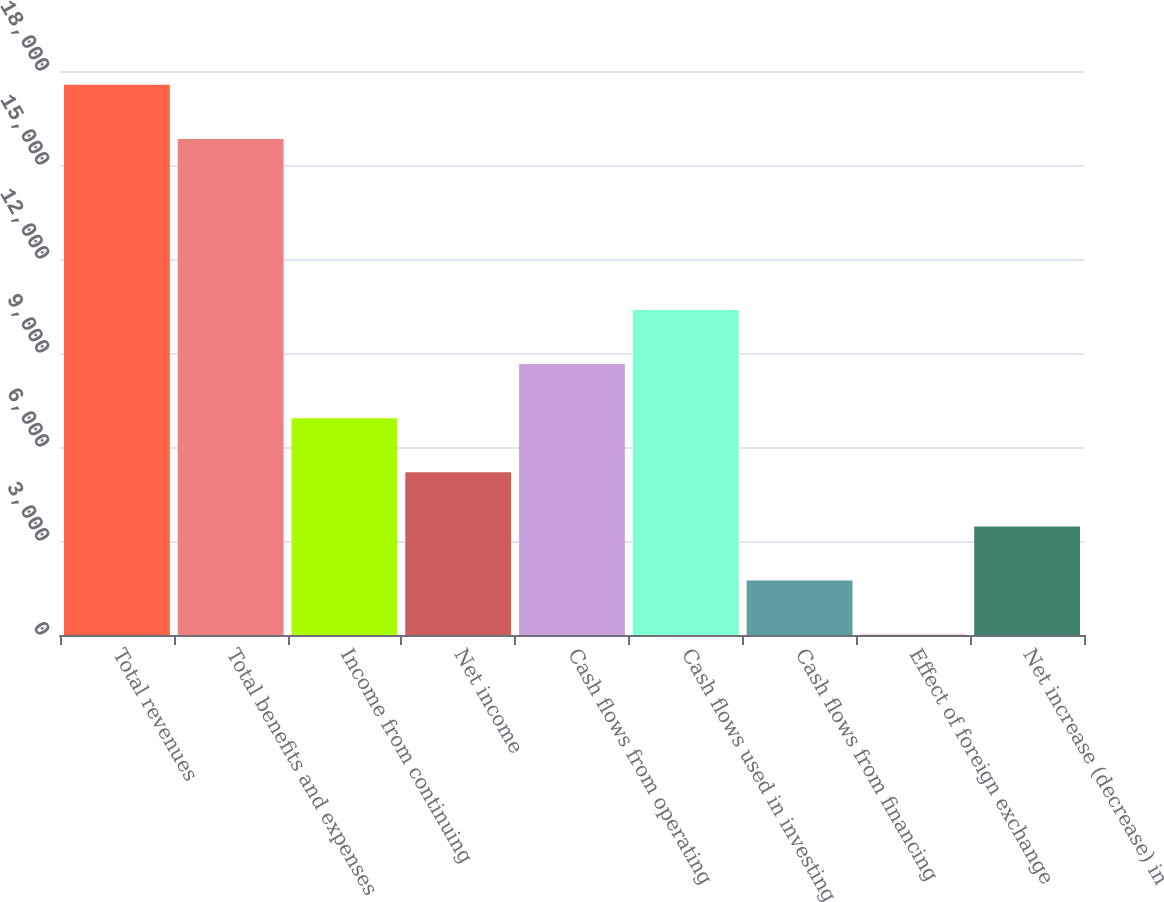Convert chart. <chart><loc_0><loc_0><loc_500><loc_500><bar_chart><fcel>Total revenues<fcel>Total benefits and expenses<fcel>Income from continuing<fcel>Net income<fcel>Cash flows from operating<fcel>Cash flows used in investing<fcel>Cash flows from financing<fcel>Effect of foreign exchange<fcel>Net increase (decrease) in<nl><fcel>17559.7<fcel>15832<fcel>6918.8<fcel>5191.1<fcel>8646.5<fcel>10374.2<fcel>1735.7<fcel>8<fcel>3463.4<nl></chart> 